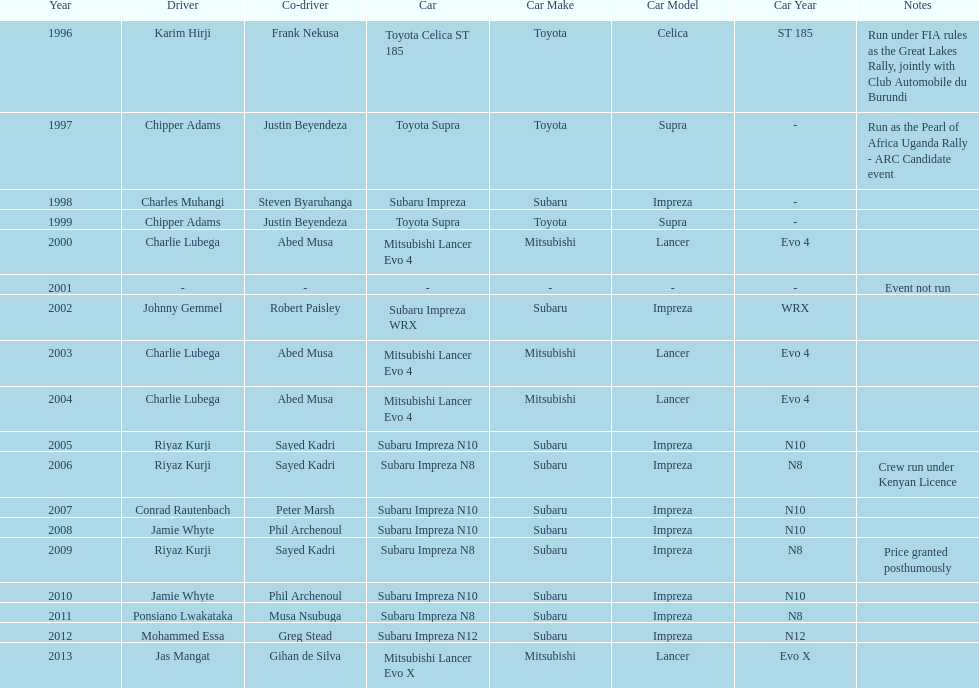Do chipper adams and justin beyendeza have more than 3 wins? No. 